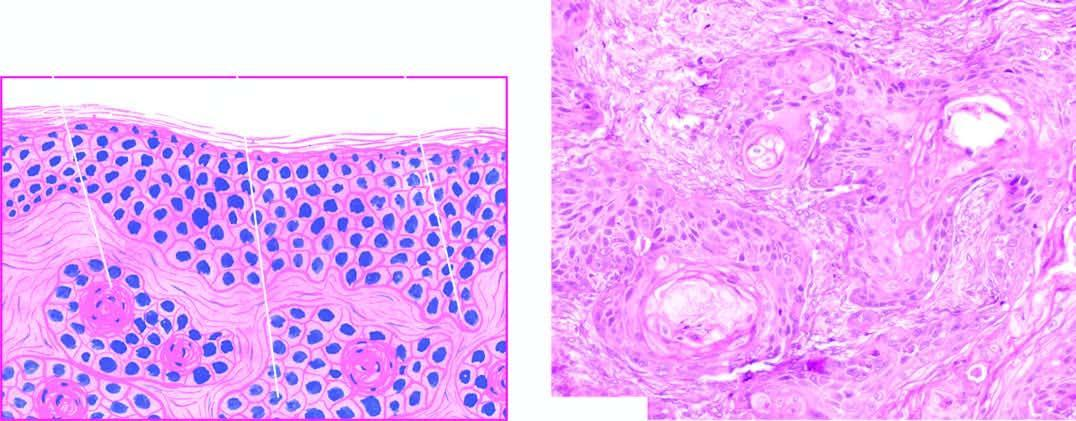re a few horn pearls with central laminated keratin present?
Answer the question using a single word or phrase. Yes 